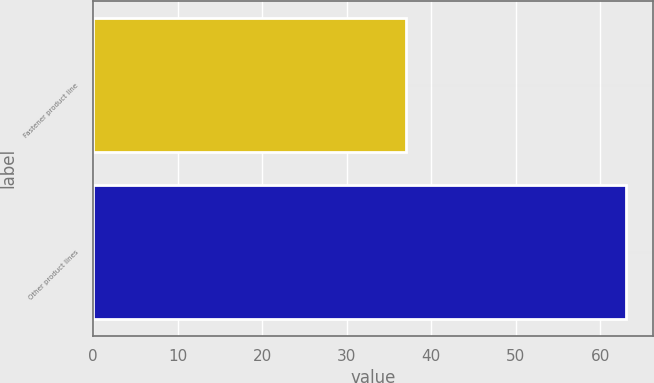Convert chart. <chart><loc_0><loc_0><loc_500><loc_500><bar_chart><fcel>Fastener product line<fcel>Other product lines<nl><fcel>37<fcel>63<nl></chart> 